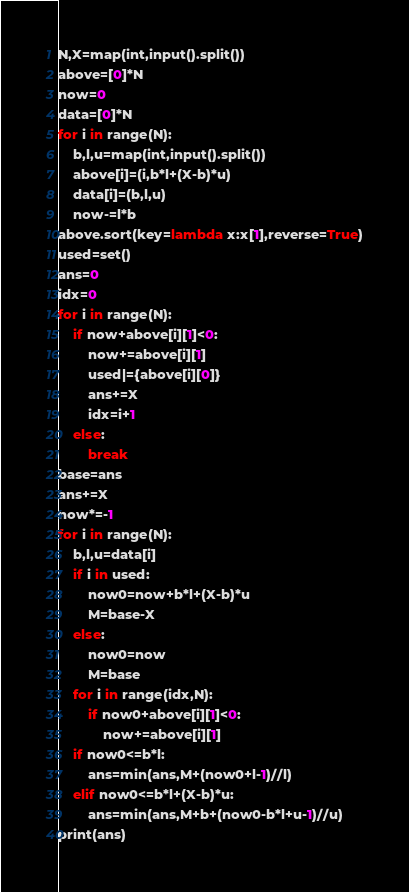Convert code to text. <code><loc_0><loc_0><loc_500><loc_500><_Python_>N,X=map(int,input().split())
above=[0]*N
now=0
data=[0]*N
for i in range(N):
    b,l,u=map(int,input().split())
    above[i]=(i,b*l+(X-b)*u)
    data[i]=(b,l,u)
    now-=l*b
above.sort(key=lambda x:x[1],reverse=True)
used=set()
ans=0
idx=0
for i in range(N):
    if now+above[i][1]<0:
        now+=above[i][1]
        used|={above[i][0]}
        ans+=X
        idx=i+1
    else:
        break
base=ans
ans+=X
now*=-1
for i in range(N):
    b,l,u=data[i]
    if i in used:
        now0=now+b*l+(X-b)*u
        M=base-X
    else:
        now0=now
        M=base
    for i in range(idx,N):
        if now0+above[i][1]<0:
            now+=above[i][1]
    if now0<=b*l:
        ans=min(ans,M+(now0+l-1)//l)
    elif now0<=b*l+(X-b)*u:
        ans=min(ans,M+b+(now0-b*l+u-1)//u)
print(ans)</code> 